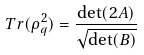<formula> <loc_0><loc_0><loc_500><loc_500>T r ( \rho _ { q } ^ { 2 } ) = \frac { \det ( 2 A ) } { \sqrt { \det ( B ) } }</formula> 